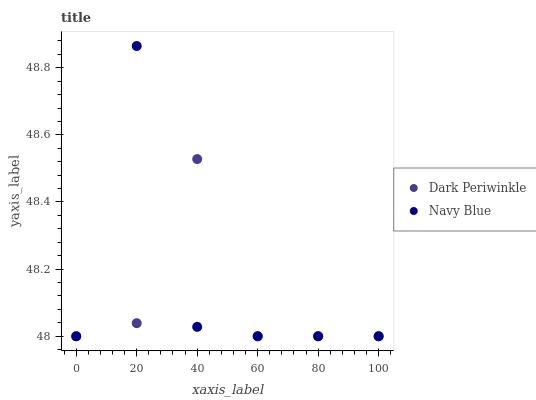Does Dark Periwinkle have the minimum area under the curve?
Answer yes or no. Yes. Does Navy Blue have the maximum area under the curve?
Answer yes or no. Yes. Does Dark Periwinkle have the maximum area under the curve?
Answer yes or no. No. Is Dark Periwinkle the smoothest?
Answer yes or no. Yes. Is Navy Blue the roughest?
Answer yes or no. Yes. Is Dark Periwinkle the roughest?
Answer yes or no. No. Does Navy Blue have the lowest value?
Answer yes or no. Yes. Does Navy Blue have the highest value?
Answer yes or no. Yes. Does Dark Periwinkle have the highest value?
Answer yes or no. No. Does Navy Blue intersect Dark Periwinkle?
Answer yes or no. Yes. Is Navy Blue less than Dark Periwinkle?
Answer yes or no. No. Is Navy Blue greater than Dark Periwinkle?
Answer yes or no. No. 